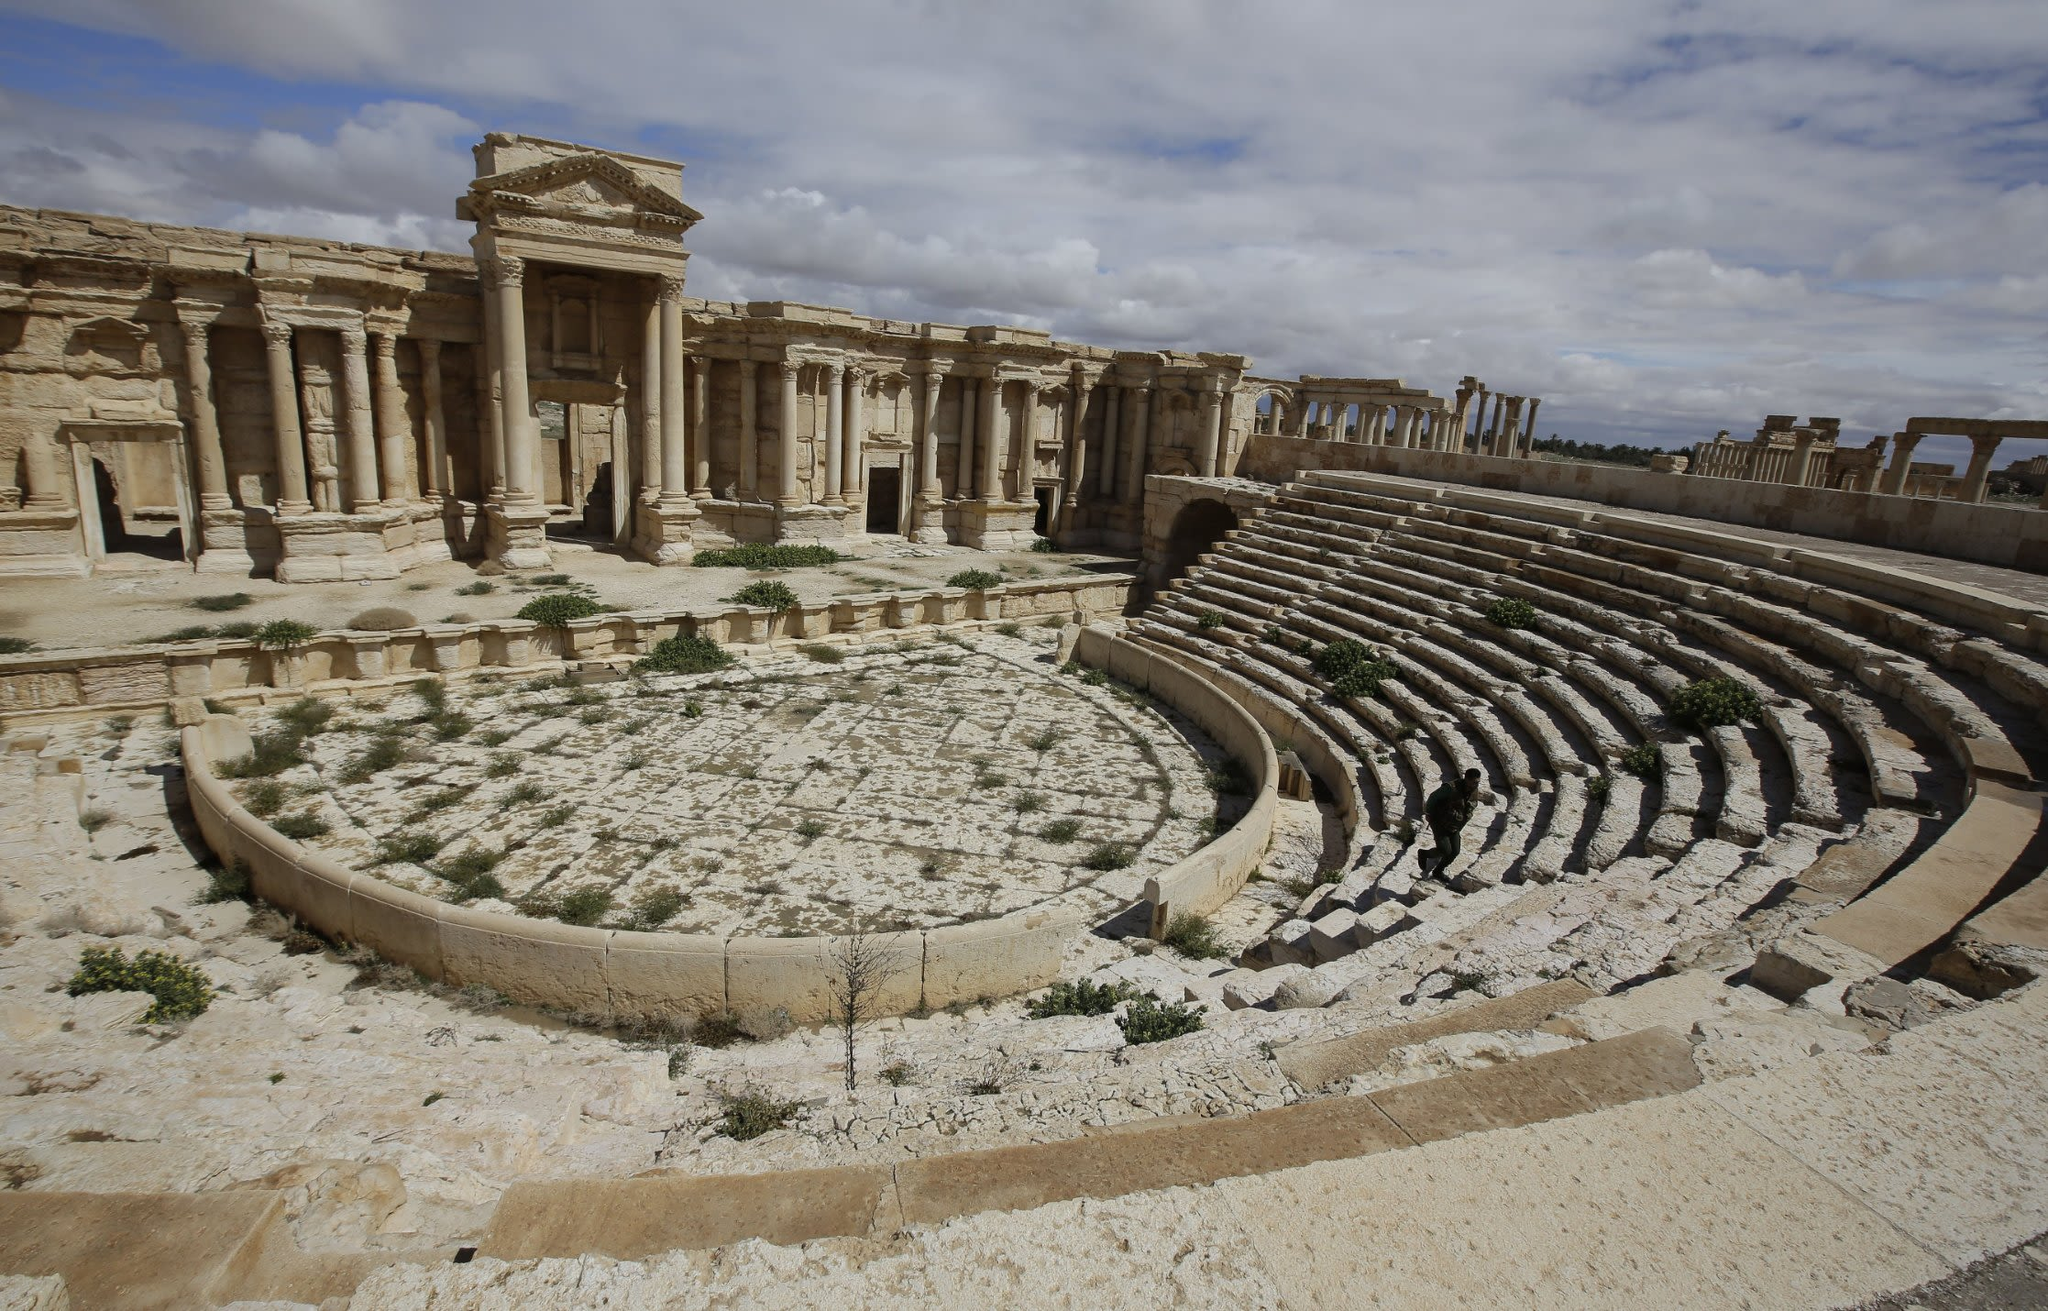What led to the current state of decay in these ruins? The ruins of Palmyra have endured through centuries of natural erosion and recent conflict-related destruction. While the natural elements have gradually worn the sandstone, significant damage occurred during the Syrian Civil War, where the site suffered due to deliberate destruction. Restoration efforts are ongoing, reflecting the global significance of preserving such historical sites. 